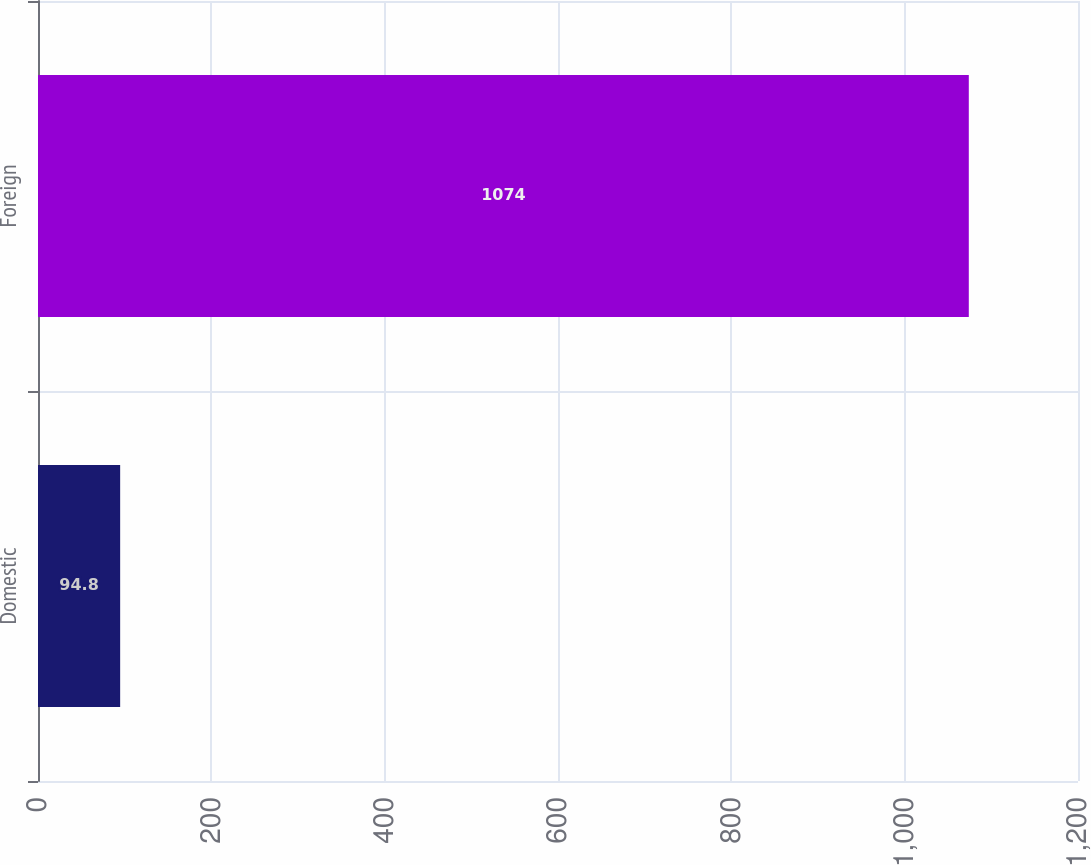<chart> <loc_0><loc_0><loc_500><loc_500><bar_chart><fcel>Domestic<fcel>Foreign<nl><fcel>94.8<fcel>1074<nl></chart> 